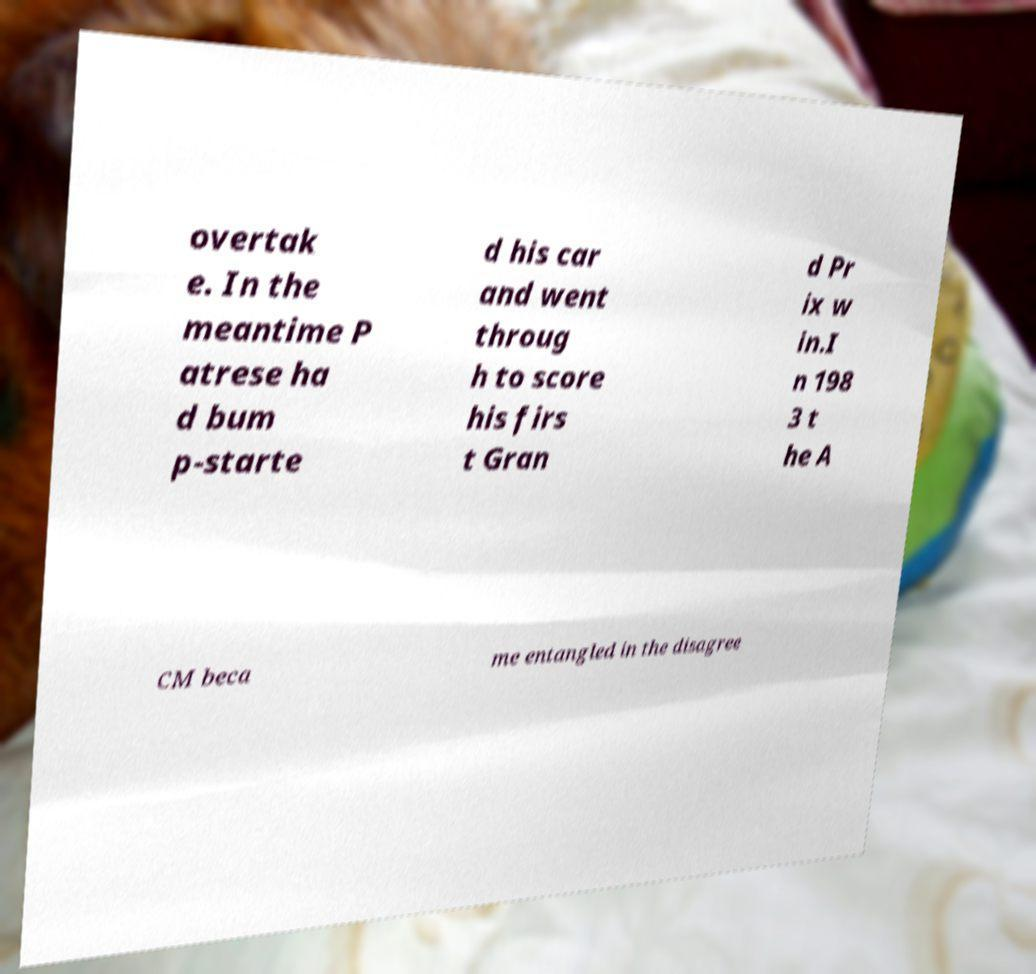There's text embedded in this image that I need extracted. Can you transcribe it verbatim? overtak e. In the meantime P atrese ha d bum p-starte d his car and went throug h to score his firs t Gran d Pr ix w in.I n 198 3 t he A CM beca me entangled in the disagree 